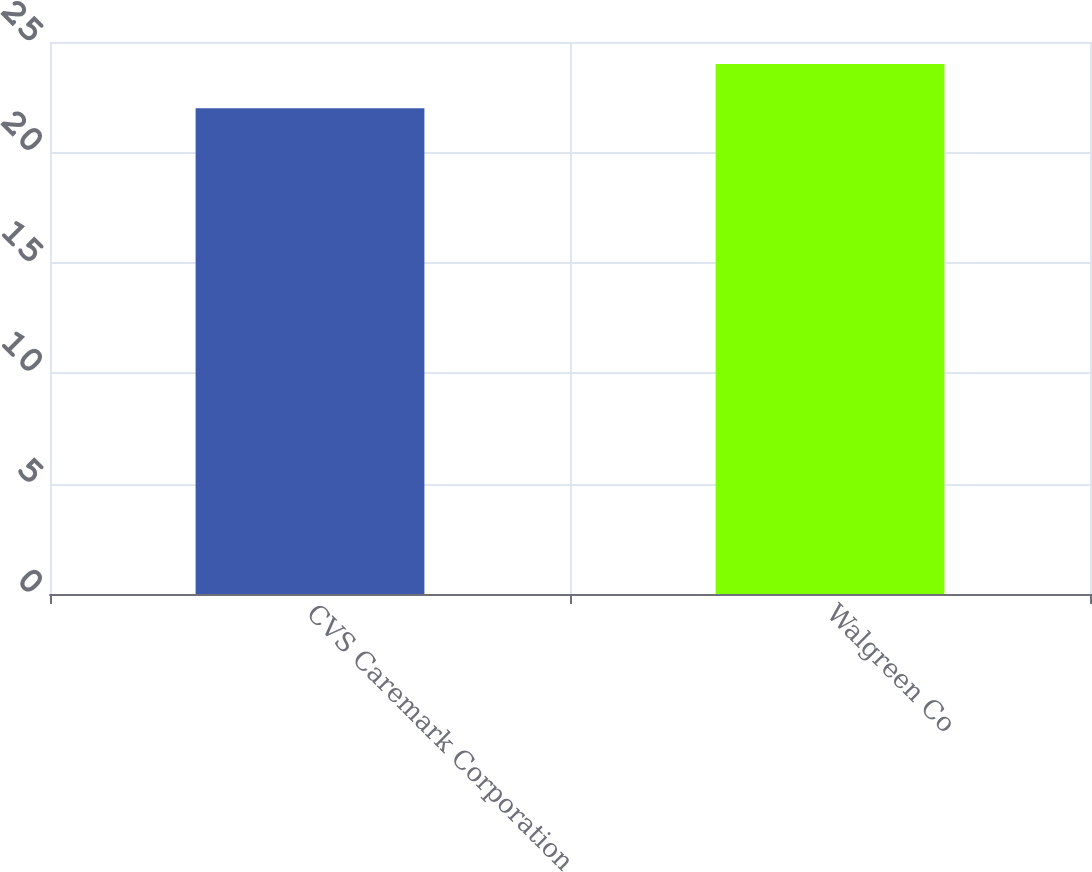Convert chart. <chart><loc_0><loc_0><loc_500><loc_500><bar_chart><fcel>CVS Caremark Corporation<fcel>Walgreen Co<nl><fcel>22<fcel>24<nl></chart> 